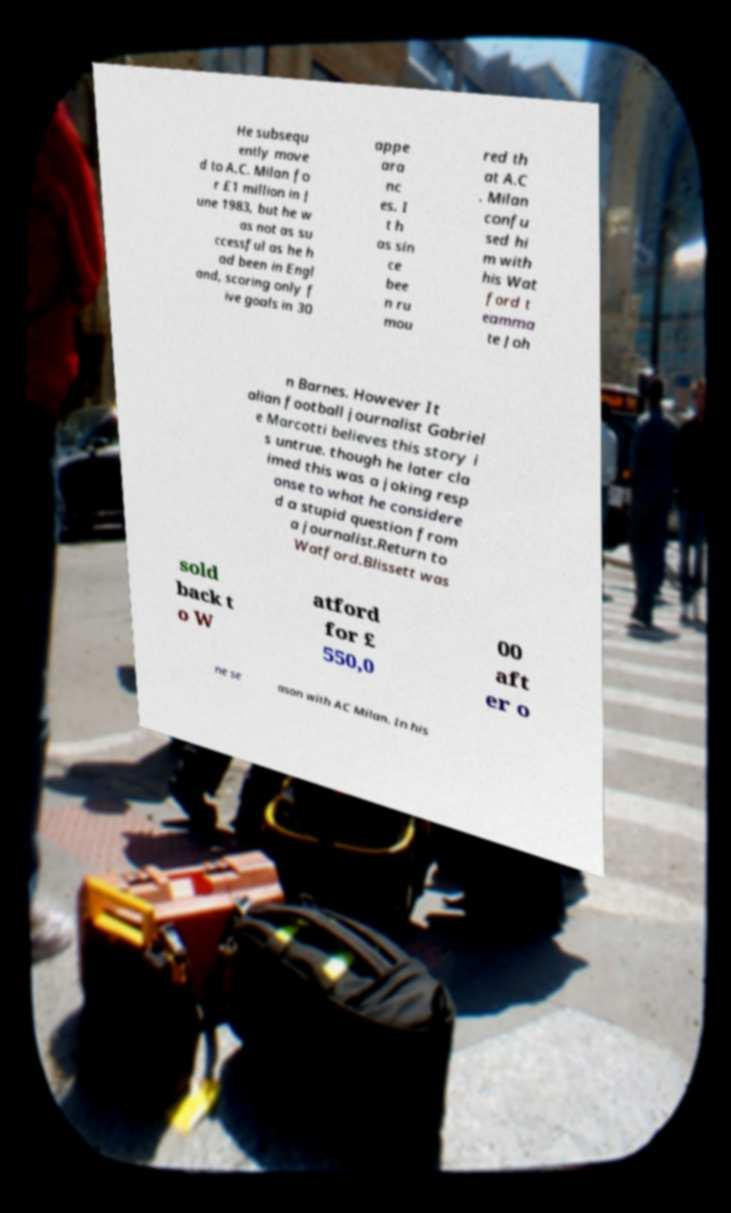Can you read and provide the text displayed in the image?This photo seems to have some interesting text. Can you extract and type it out for me? He subsequ ently move d to A.C. Milan fo r £1 million in J une 1983, but he w as not as su ccessful as he h ad been in Engl and, scoring only f ive goals in 30 appe ara nc es. I t h as sin ce bee n ru mou red th at A.C . Milan confu sed hi m with his Wat ford t eamma te Joh n Barnes. However It alian football journalist Gabriel e Marcotti believes this story i s untrue. though he later cla imed this was a joking resp onse to what he considere d a stupid question from a journalist.Return to Watford.Blissett was sold back t o W atford for £ 550,0 00 aft er o ne se ason with AC Milan. In his 